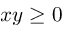<formula> <loc_0><loc_0><loc_500><loc_500>x y \geq 0</formula> 